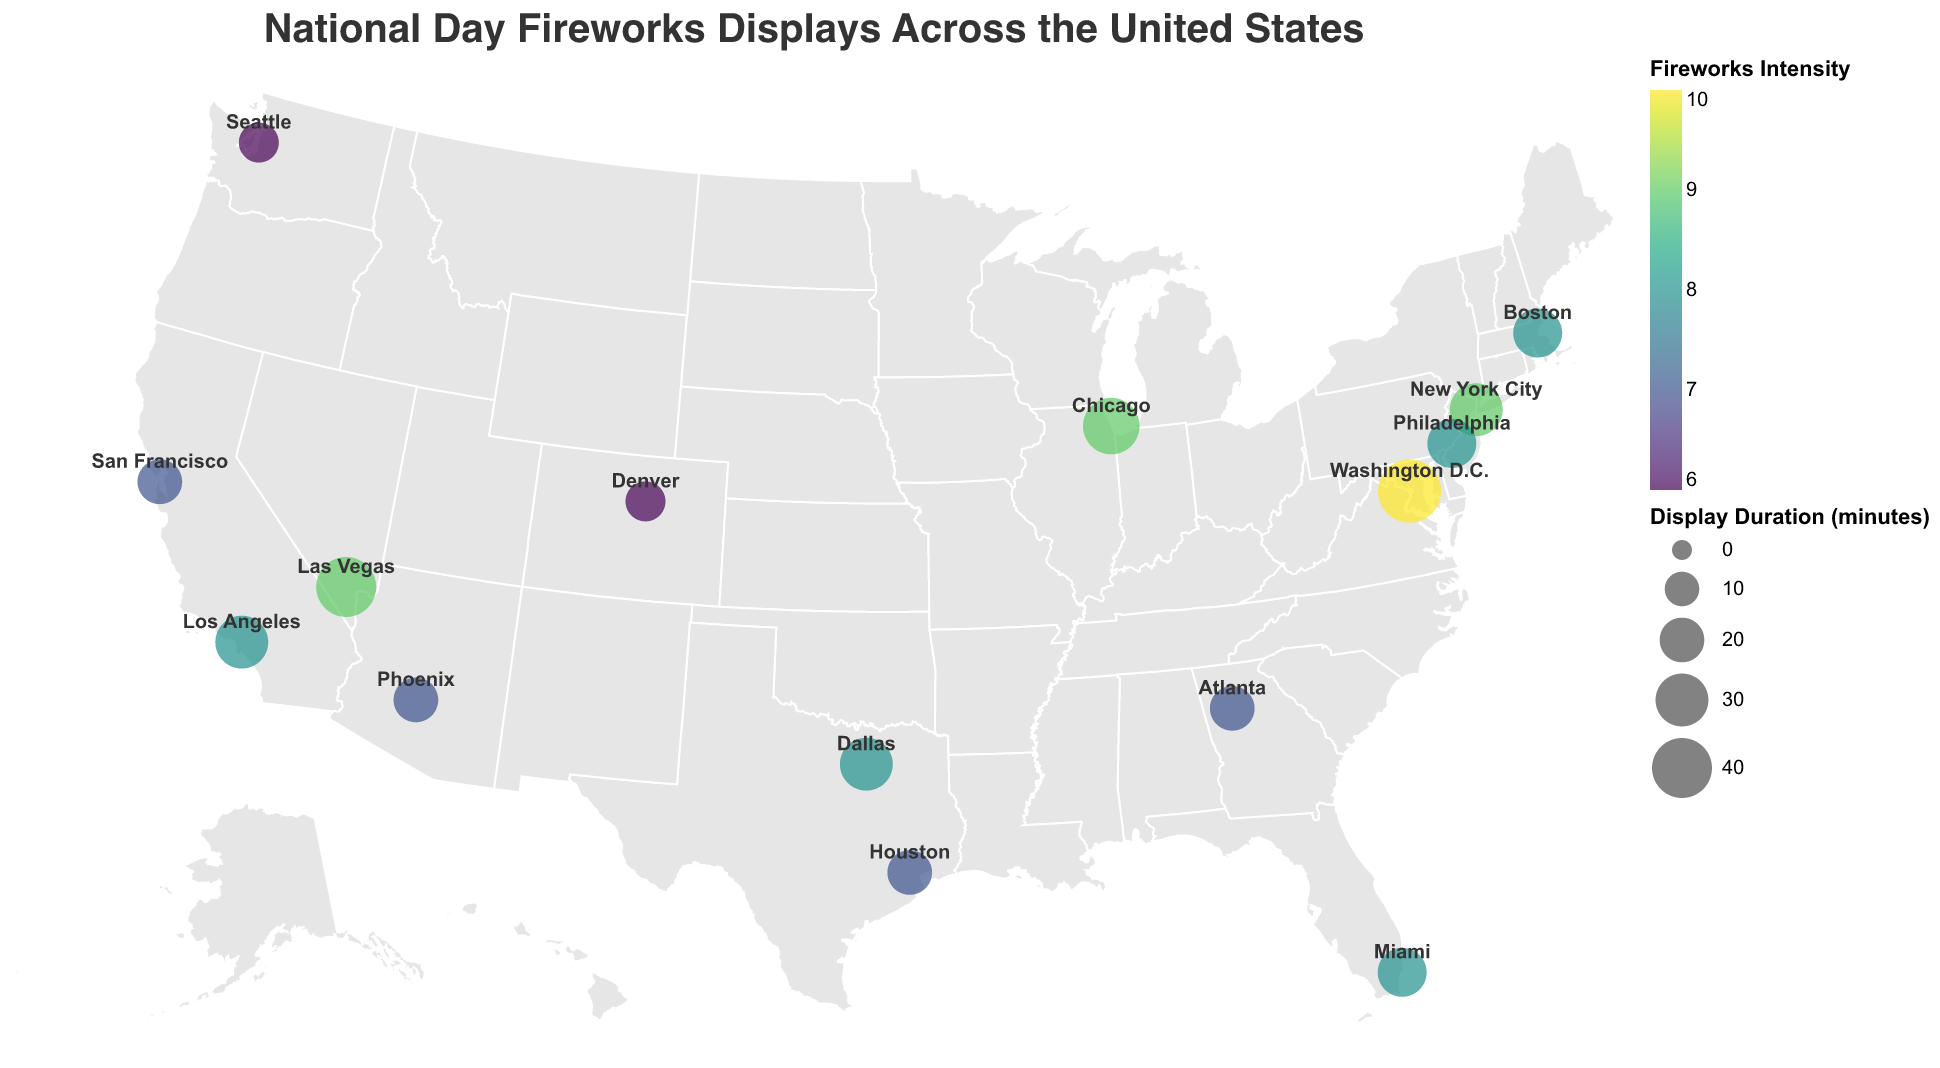How many cities display fireworks on National Day? Count the number of circles representing cities on the map.
Answer: 15 Which city has the highest fireworks intensity? Identify the city with the darkest color circle which represents the highest fireworks intensity value.
Answer: Washington D.C What is the average duration of fireworks displays across all cities? Sum all the display durations and divide by the number of cities: (30 + 45 + 25 + 35 + 30 + 20 + 25 + 20 + 15 + 20 + 15 + 40 + 25 + 20 + 30) / 15 = 25.67.
Answer: 25.67 Are there more cities with a fireworks intensity of 8 or 7? Count the cities with a fireworks intensity of 8 and 7. Intensity 8: Boston, Los Angeles, Miami, Philadelphia, Dallas (5 cities). Intensity 7: San Francisco, Houston, Atlanta, Phoenix (4 cities).
Answer: Intensity 8 Which city has a longer display duration, New York City or Las Vegas? Compare the display durations of New York City (30 minutes) and Las Vegas (40 minutes).
Answer: Las Vegas What is the total duration of all the fireworks displays in cities with a fireworks intensity of 7? Sum the display durations of cities with an intensity of 7: San Francisco (20) + Houston (20) + Atlanta (20) + Phoenix (20) = 80 minutes.
Answer: 80 Between Chicago and Miami, which city has a higher fireworks intensity? Compare the fireworks intensity values of Chicago (9) and Miami (8).
Answer: Chicago How does the display duration in Washington D.C. compare to that in Denver? Compare the display durations of Washington D.C. (45 minutes) and Denver (15 minutes).
Answer: Washington D.C Which cities have a fireworks intensity lower than 8? Identify the cities with an intensity value less than 8: San Francisco, Houston, Seattle, Atlanta, Denver, Phoenix.
Answer: San Francisco, Houston, Seattle, Atlanta, Denver, Phoenix What is the median fireworks intensity across all cities? Sort the intensity values and find the middle value. The sorted intensities are: 6, 6, 7, 7, 7, 7, 8, 8, 8, 8, 8, 9, 9, 9, 10. The middle value is the 8th value, which is 8.
Answer: 8 